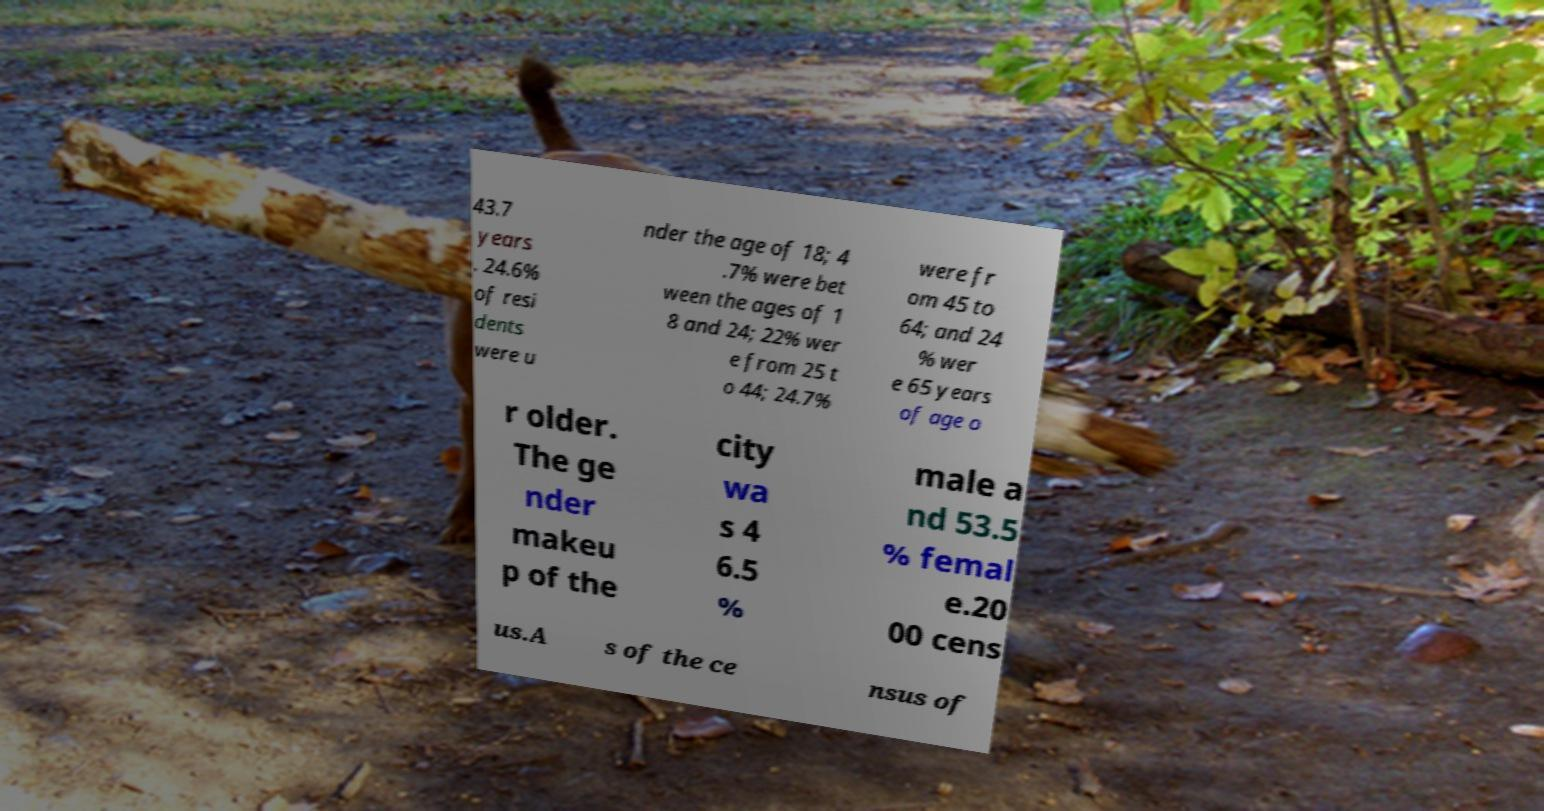For documentation purposes, I need the text within this image transcribed. Could you provide that? 43.7 years . 24.6% of resi dents were u nder the age of 18; 4 .7% were bet ween the ages of 1 8 and 24; 22% wer e from 25 t o 44; 24.7% were fr om 45 to 64; and 24 % wer e 65 years of age o r older. The ge nder makeu p of the city wa s 4 6.5 % male a nd 53.5 % femal e.20 00 cens us.A s of the ce nsus of 